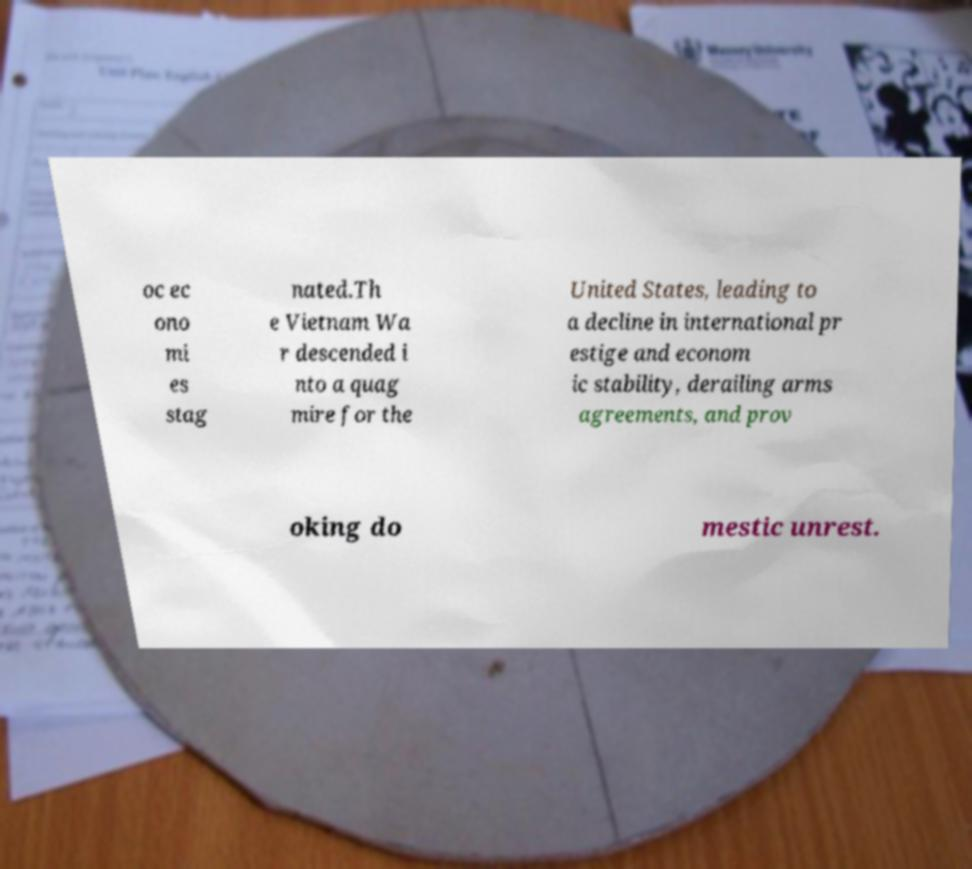Can you accurately transcribe the text from the provided image for me? oc ec ono mi es stag nated.Th e Vietnam Wa r descended i nto a quag mire for the United States, leading to a decline in international pr estige and econom ic stability, derailing arms agreements, and prov oking do mestic unrest. 